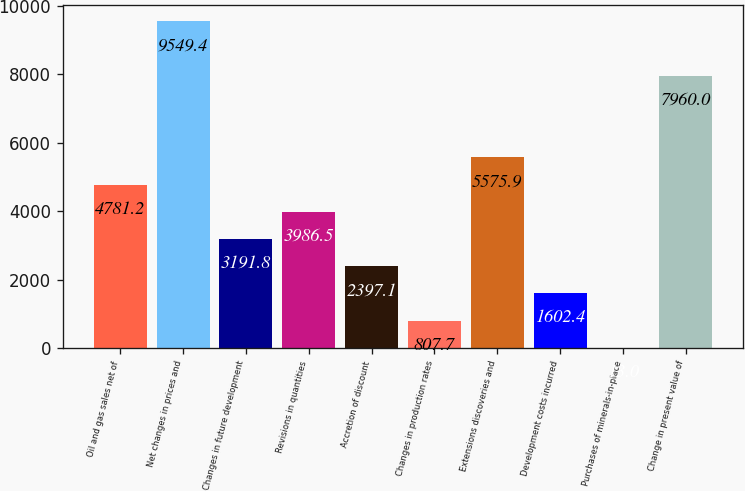<chart> <loc_0><loc_0><loc_500><loc_500><bar_chart><fcel>Oil and gas sales net of<fcel>Net changes in prices and<fcel>Changes in future development<fcel>Revisions in quantities<fcel>Accretion of discount<fcel>Changes in production rates<fcel>Extensions discoveries and<fcel>Development costs incurred<fcel>Purchases of minerals-in-place<fcel>Change in present value of<nl><fcel>4781.2<fcel>9549.4<fcel>3191.8<fcel>3986.5<fcel>2397.1<fcel>807.7<fcel>5575.9<fcel>1602.4<fcel>13<fcel>7960<nl></chart> 